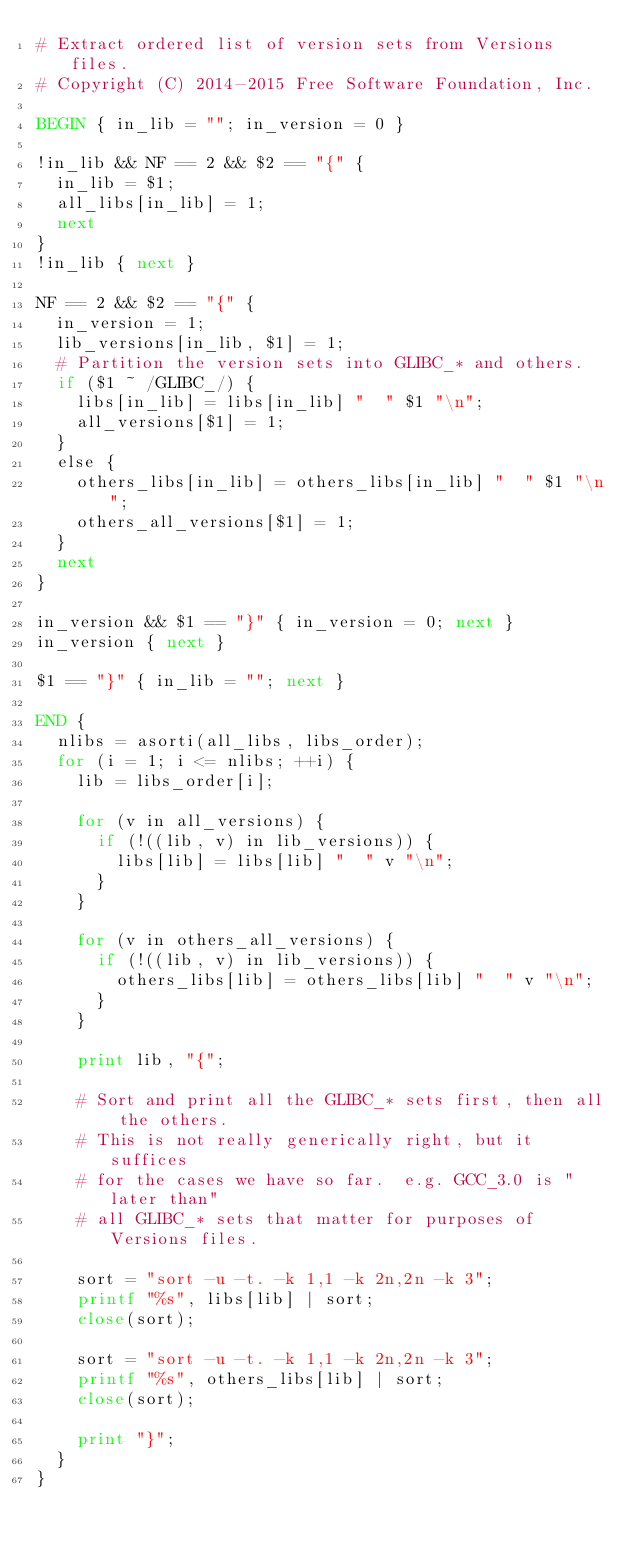Convert code to text. <code><loc_0><loc_0><loc_500><loc_500><_Awk_># Extract ordered list of version sets from Versions files.
# Copyright (C) 2014-2015 Free Software Foundation, Inc.

BEGIN { in_lib = ""; in_version = 0 }

!in_lib && NF == 2 && $2 == "{" {
  in_lib = $1;
  all_libs[in_lib] = 1;
  next
}
!in_lib { next }

NF == 2 && $2 == "{" {
  in_version = 1;
  lib_versions[in_lib, $1] = 1;
  # Partition the version sets into GLIBC_* and others.
  if ($1 ~ /GLIBC_/) {
    libs[in_lib] = libs[in_lib] "  " $1 "\n";
    all_versions[$1] = 1;
  }
  else {
    others_libs[in_lib] = others_libs[in_lib] "  " $1 "\n";
    others_all_versions[$1] = 1;
  }
  next
}

in_version && $1 == "}" { in_version = 0; next }
in_version { next }

$1 == "}" { in_lib = ""; next }

END {
  nlibs = asorti(all_libs, libs_order);
  for (i = 1; i <= nlibs; ++i) {
    lib = libs_order[i];

    for (v in all_versions) {
      if (!((lib, v) in lib_versions)) {
        libs[lib] = libs[lib] "  " v "\n";
      }
    }

    for (v in others_all_versions) {
      if (!((lib, v) in lib_versions)) {
        others_libs[lib] = others_libs[lib] "  " v "\n";
      }
    }

    print lib, "{";

    # Sort and print all the GLIBC_* sets first, then all the others.
    # This is not really generically right, but it suffices
    # for the cases we have so far.  e.g. GCC_3.0 is "later than"
    # all GLIBC_* sets that matter for purposes of Versions files.

    sort = "sort -u -t. -k 1,1 -k 2n,2n -k 3";
    printf "%s", libs[lib] | sort;
    close(sort);

    sort = "sort -u -t. -k 1,1 -k 2n,2n -k 3";
    printf "%s", others_libs[lib] | sort;
    close(sort);

    print "}";
  }
}
</code> 